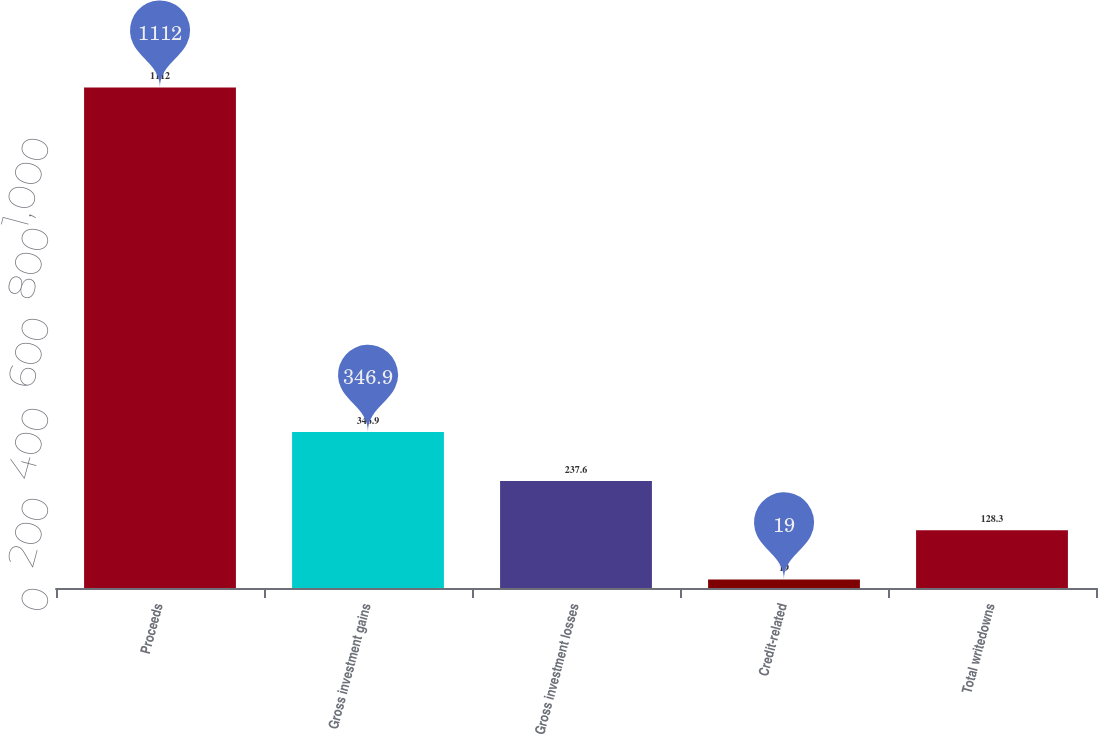Convert chart to OTSL. <chart><loc_0><loc_0><loc_500><loc_500><bar_chart><fcel>Proceeds<fcel>Gross investment gains<fcel>Gross investment losses<fcel>Credit-related<fcel>Total writedowns<nl><fcel>1112<fcel>346.9<fcel>237.6<fcel>19<fcel>128.3<nl></chart> 